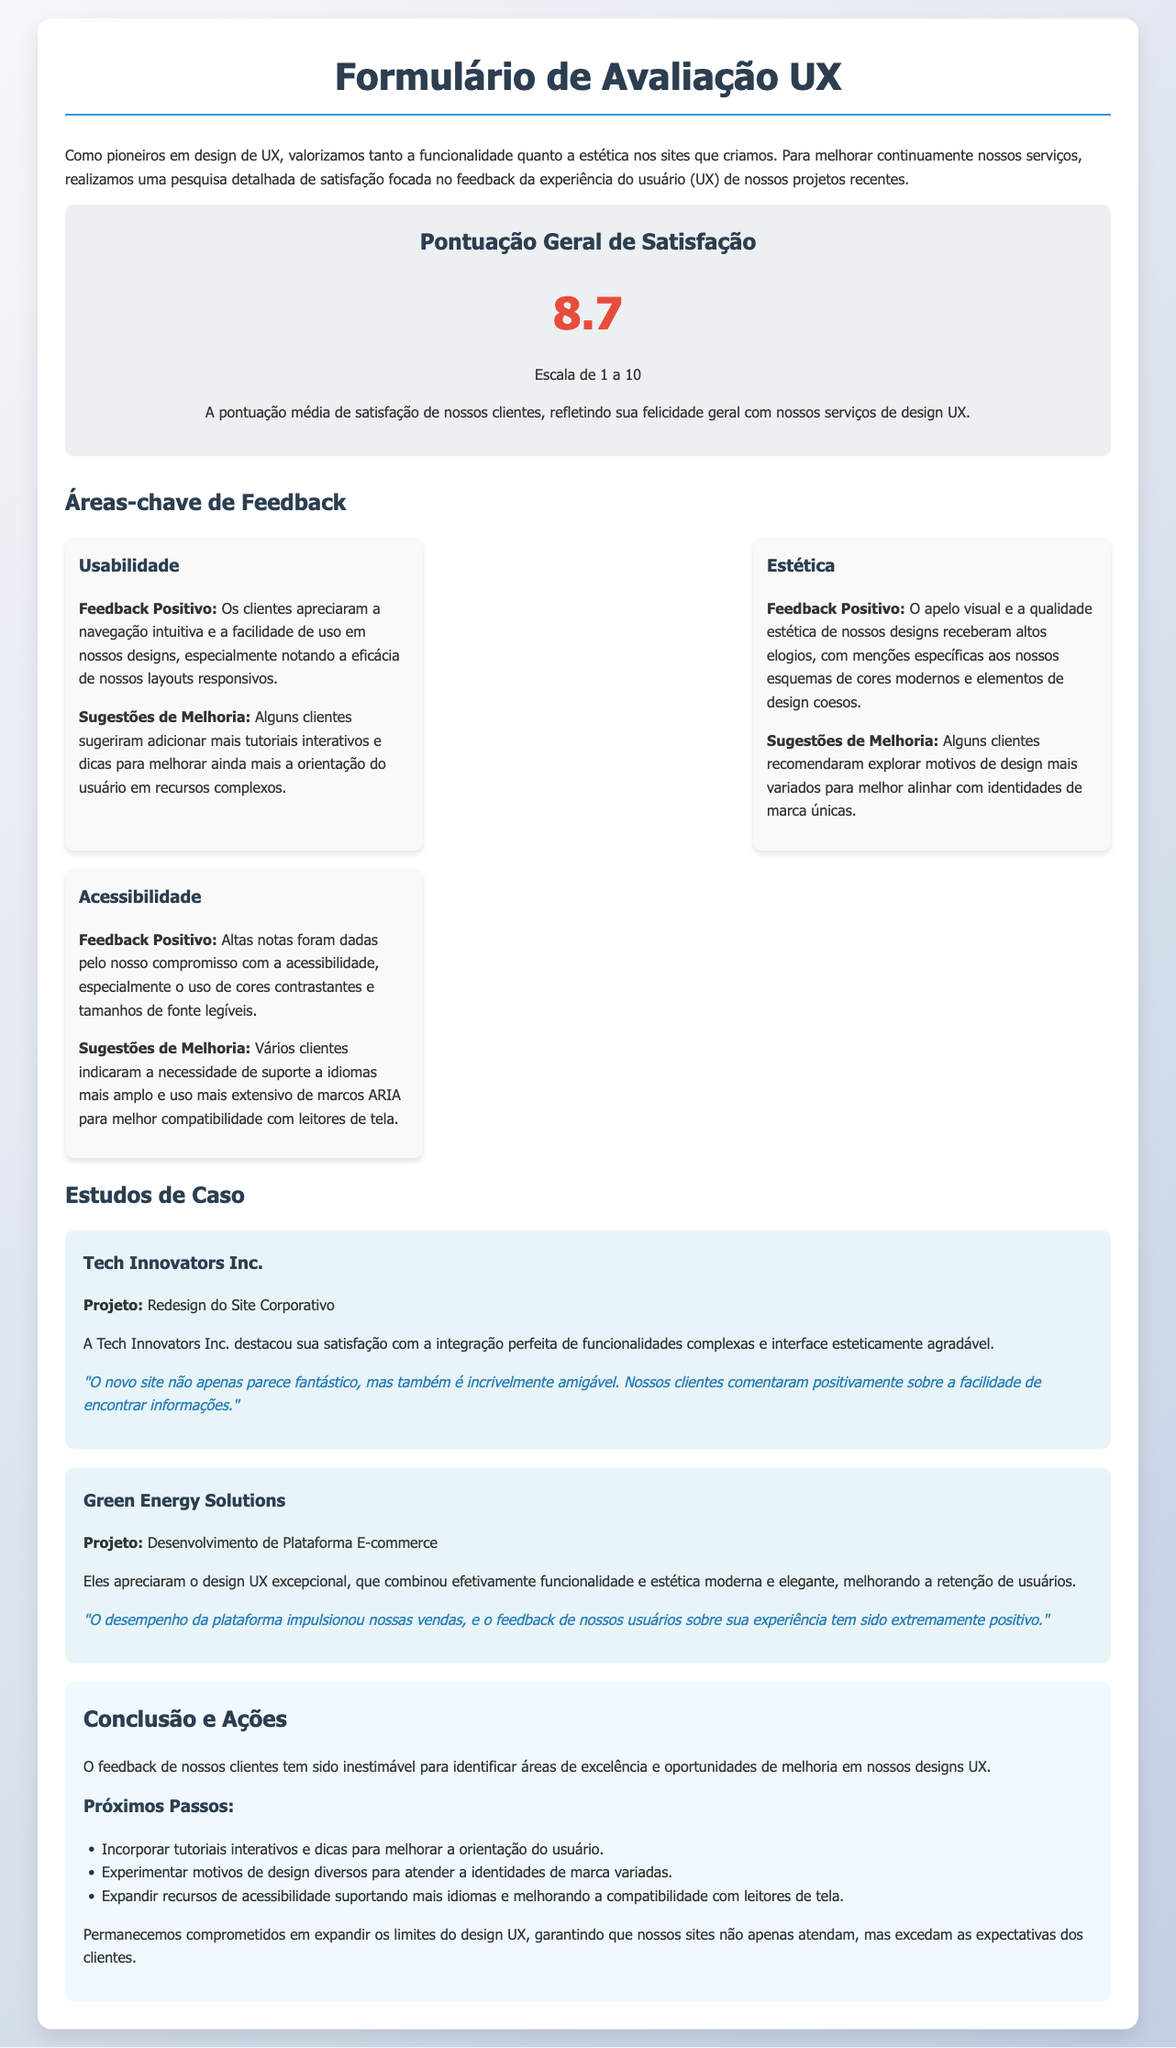qual é a pontuação geral de satisfação? A pontuação geral de satisfação é apresentada na seção de satisfação do documento, que é 8.7.
Answer: 8.7 qual é um feedback positivo sobre usabilidade? O feedback positivo em relação à usabilidade menciona a navegação intuitiva e a facilidade de uso em nossos designs.
Answer: Navegação intuitiva quais são as sugestões de melhoria para acessibilidade? As sugestões de melhoria para acessibilidade incluem o suporte a idiomas mais amplo e o uso mais extensivo de marcos ARIA.
Answer: Suporte a idiomas mais amplo quem elogiou o redesign do site corporativo? A empresa que elogiou o redesign do site corporativo foi a Tech Innovators Inc.
Answer: Tech Innovators Inc quais são os próximos passos mencionados no documento? Os próximos passos incluem incorporar tutoriais interativos, experimentar motivos de design diversos e expandir recursos de acessibilidade.
Answer: Incorporar tutoriais interativos qual foi um feedback positivo sobre estética? O feedback positivo sobre estética elogia o apelo visual e a qualidade estética dos designs.
Answer: Apelo visual o que a Tech Innovators Inc. destacou sobre seu novo site? A Tech Innovators Inc. destacou a integração perfeita de funcionalidades complexas e interface agradável.
Answer: Integração perfeita de funcionalidades qual foi o projeto de Green Energy Solutions? O projeto de Green Energy Solutions mencionado no documento é o desenvolvimento de uma plataforma e-commerce.
Answer: Desenvolvimento de Plataforma E-commerce 